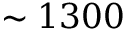Convert formula to latex. <formula><loc_0><loc_0><loc_500><loc_500>\sim 1 3 0 0</formula> 